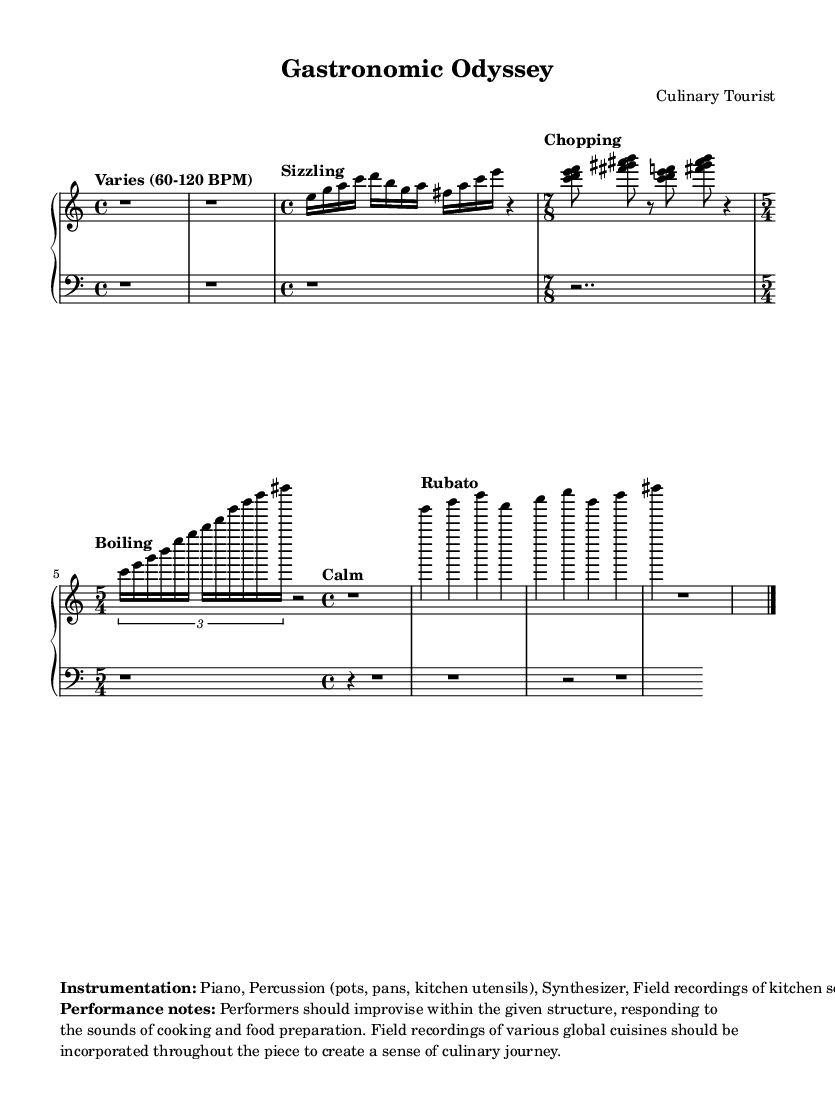What is the time signature of Section B? The time signature of Section B is indicated as 7/8, which can be found in the notated section.
Answer: 7/8 What instruments are used in this piece? The instruments listed in the markup section include Piano, Percussion (pots, pans, kitchen utensils), Synthesizer, and Field recordings.
Answer: Piano, Percussion, Synthesizer, Field recordings What is the tempo marking for Section A? The tempo marking for Section A is specified as "Sizzling" and can be found at the beginning of that section.
Answer: Sizzling How many measures are in Section D? Section D consists of a series of four quarter notes (g, b, d, a) followed by two eighth notes (c, e), which means it has six total notes, suggesting there are two measures altogether as quarter notes occupy one measure each.
Answer: 2 What kinds of sounds are encouraged to be incorporated during the performance? The performance notes suggest incorporating field recordings of various global cuisines, in addition to improvisation. This is aimed at enhancing the culinary journey experience.
Answer: Field recordings of various global cuisines What is the primary theme of the composition? The title "Gastronomic Odyssey" and the specific instructions suggest that the theme revolves around a journey through cooking and global culinary techniques.
Answer: Culinary journey 